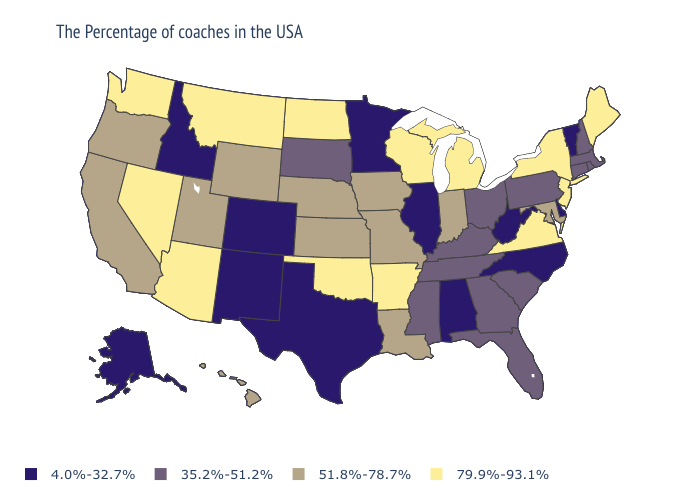What is the highest value in the South ?
Answer briefly. 79.9%-93.1%. What is the lowest value in the USA?
Short answer required. 4.0%-32.7%. What is the lowest value in the Northeast?
Keep it brief. 4.0%-32.7%. What is the value of New Jersey?
Quick response, please. 79.9%-93.1%. Which states have the lowest value in the USA?
Give a very brief answer. Vermont, Delaware, North Carolina, West Virginia, Alabama, Illinois, Minnesota, Texas, Colorado, New Mexico, Idaho, Alaska. What is the lowest value in the South?
Write a very short answer. 4.0%-32.7%. What is the highest value in states that border California?
Be succinct. 79.9%-93.1%. Does Idaho have the lowest value in the USA?
Quick response, please. Yes. Does Iowa have the lowest value in the USA?
Be succinct. No. What is the lowest value in the USA?
Answer briefly. 4.0%-32.7%. What is the lowest value in the West?
Be succinct. 4.0%-32.7%. Name the states that have a value in the range 51.8%-78.7%?
Answer briefly. Maryland, Indiana, Louisiana, Missouri, Iowa, Kansas, Nebraska, Wyoming, Utah, California, Oregon, Hawaii. Name the states that have a value in the range 35.2%-51.2%?
Concise answer only. Massachusetts, Rhode Island, New Hampshire, Connecticut, Pennsylvania, South Carolina, Ohio, Florida, Georgia, Kentucky, Tennessee, Mississippi, South Dakota. What is the value of Kentucky?
Be succinct. 35.2%-51.2%. 